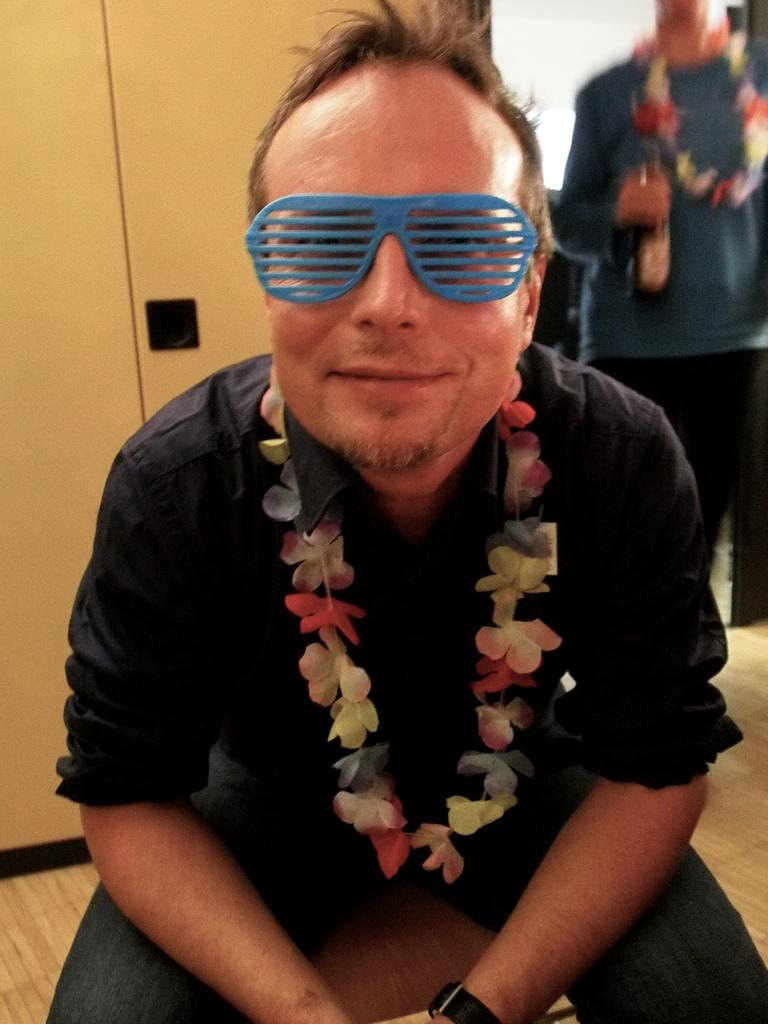What is the position of the person in the image? There is a person sitting on a chair in the image, and another person standing. What is the standing person holding? The standing person is holding a bottle. What can be seen in the background of the image? There is a cupboard in the background of the image. Can you tell me how many dinosaurs are present in the image? There are no dinosaurs present in the image. What is the example of an end in the image? There is no specific example of an "end" in the image; the image primarily features people and a cupboard. 